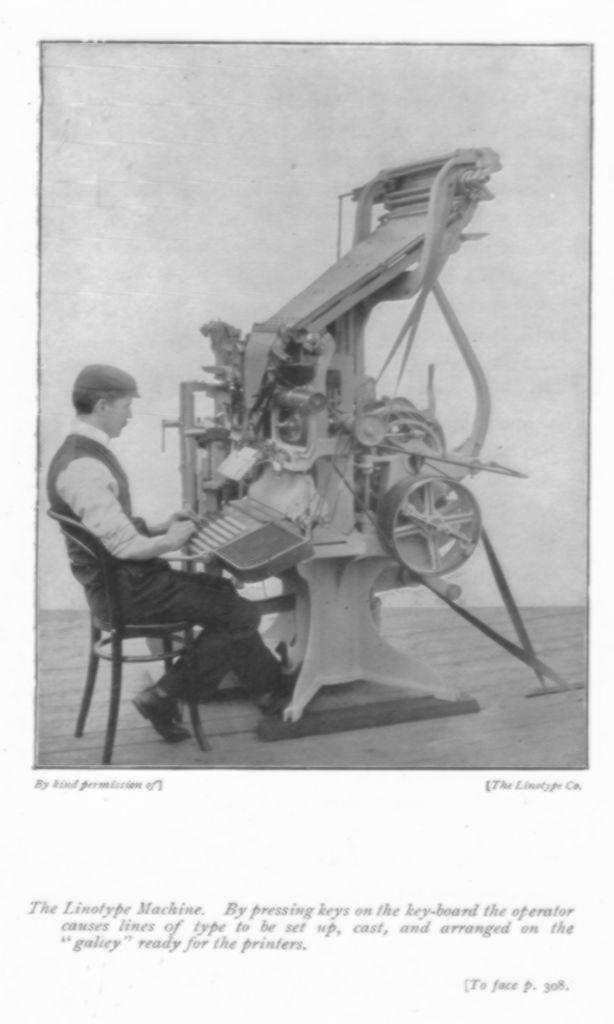What is the person in the image doing? The person is sitting on a chair in the image. What is in front of the person? There is a machine and a keyboard in front of the person. What is the color scheme of the image? The image is in black and white. What type of door can be seen in the image? There is no door present in the image. What is the person in the image writing on the keyboard? The image is in black and white, and there is no indication of any writing or activity on the keyboard. 